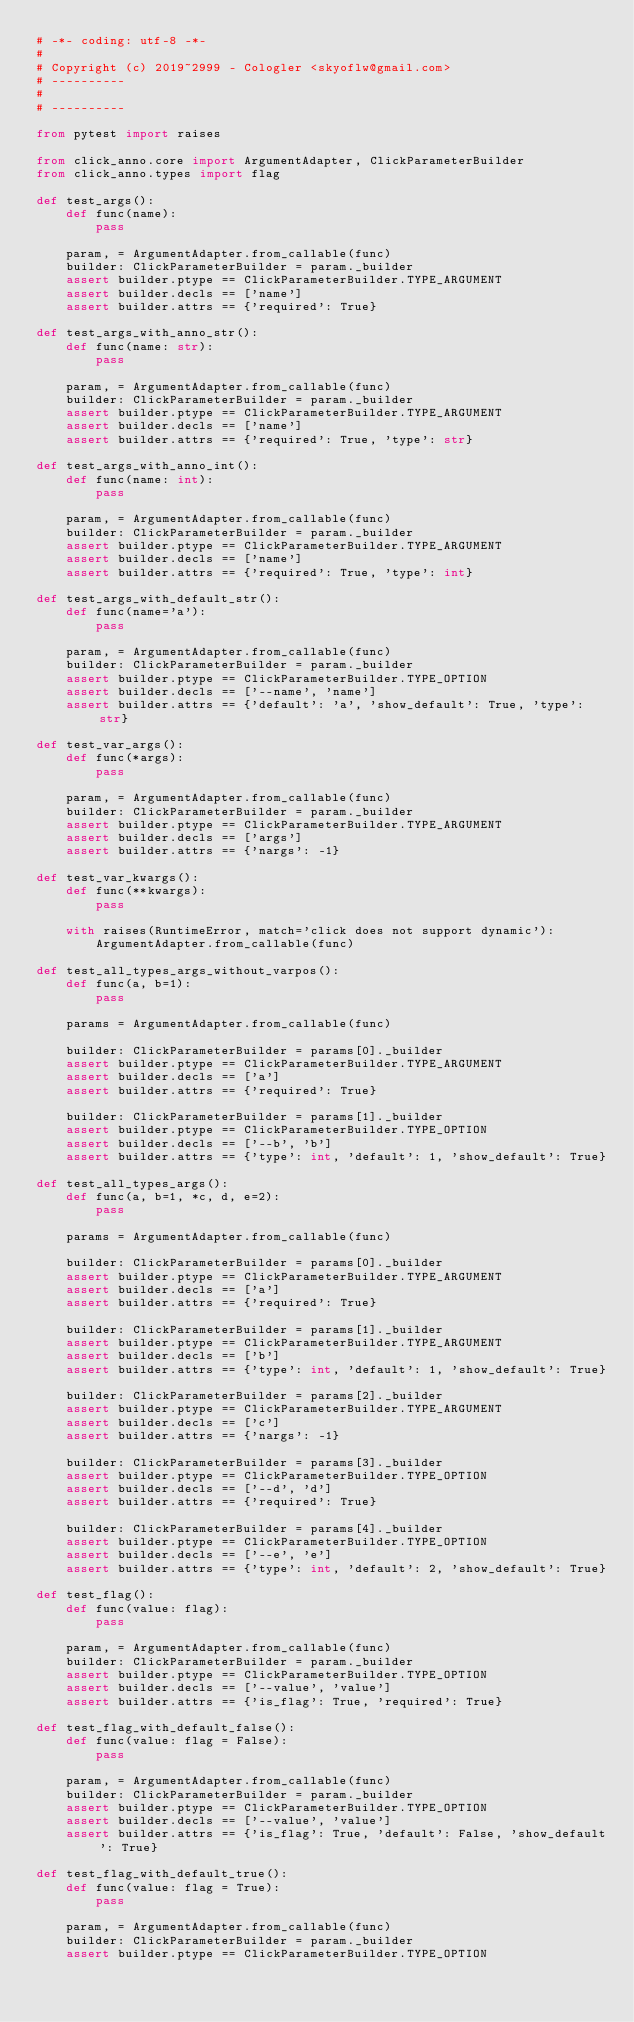<code> <loc_0><loc_0><loc_500><loc_500><_Python_># -*- coding: utf-8 -*-
#
# Copyright (c) 2019~2999 - Cologler <skyoflw@gmail.com>
# ----------
#
# ----------

from pytest import raises

from click_anno.core import ArgumentAdapter, ClickParameterBuilder
from click_anno.types import flag

def test_args():
    def func(name):
        pass

    param, = ArgumentAdapter.from_callable(func)
    builder: ClickParameterBuilder = param._builder
    assert builder.ptype == ClickParameterBuilder.TYPE_ARGUMENT
    assert builder.decls == ['name']
    assert builder.attrs == {'required': True}

def test_args_with_anno_str():
    def func(name: str):
        pass

    param, = ArgumentAdapter.from_callable(func)
    builder: ClickParameterBuilder = param._builder
    assert builder.ptype == ClickParameterBuilder.TYPE_ARGUMENT
    assert builder.decls == ['name']
    assert builder.attrs == {'required': True, 'type': str}

def test_args_with_anno_int():
    def func(name: int):
        pass

    param, = ArgumentAdapter.from_callable(func)
    builder: ClickParameterBuilder = param._builder
    assert builder.ptype == ClickParameterBuilder.TYPE_ARGUMENT
    assert builder.decls == ['name']
    assert builder.attrs == {'required': True, 'type': int}

def test_args_with_default_str():
    def func(name='a'):
        pass

    param, = ArgumentAdapter.from_callable(func)
    builder: ClickParameterBuilder = param._builder
    assert builder.ptype == ClickParameterBuilder.TYPE_OPTION
    assert builder.decls == ['--name', 'name']
    assert builder.attrs == {'default': 'a', 'show_default': True, 'type': str}

def test_var_args():
    def func(*args):
        pass

    param, = ArgumentAdapter.from_callable(func)
    builder: ClickParameterBuilder = param._builder
    assert builder.ptype == ClickParameterBuilder.TYPE_ARGUMENT
    assert builder.decls == ['args']
    assert builder.attrs == {'nargs': -1}

def test_var_kwargs():
    def func(**kwargs):
        pass

    with raises(RuntimeError, match='click does not support dynamic'):
        ArgumentAdapter.from_callable(func)

def test_all_types_args_without_varpos():
    def func(a, b=1):
        pass

    params = ArgumentAdapter.from_callable(func)

    builder: ClickParameterBuilder = params[0]._builder
    assert builder.ptype == ClickParameterBuilder.TYPE_ARGUMENT
    assert builder.decls == ['a']
    assert builder.attrs == {'required': True}

    builder: ClickParameterBuilder = params[1]._builder
    assert builder.ptype == ClickParameterBuilder.TYPE_OPTION
    assert builder.decls == ['--b', 'b']
    assert builder.attrs == {'type': int, 'default': 1, 'show_default': True}

def test_all_types_args():
    def func(a, b=1, *c, d, e=2):
        pass

    params = ArgumentAdapter.from_callable(func)

    builder: ClickParameterBuilder = params[0]._builder
    assert builder.ptype == ClickParameterBuilder.TYPE_ARGUMENT
    assert builder.decls == ['a']
    assert builder.attrs == {'required': True}

    builder: ClickParameterBuilder = params[1]._builder
    assert builder.ptype == ClickParameterBuilder.TYPE_ARGUMENT
    assert builder.decls == ['b']
    assert builder.attrs == {'type': int, 'default': 1, 'show_default': True}

    builder: ClickParameterBuilder = params[2]._builder
    assert builder.ptype == ClickParameterBuilder.TYPE_ARGUMENT
    assert builder.decls == ['c']
    assert builder.attrs == {'nargs': -1}

    builder: ClickParameterBuilder = params[3]._builder
    assert builder.ptype == ClickParameterBuilder.TYPE_OPTION
    assert builder.decls == ['--d', 'd']
    assert builder.attrs == {'required': True}

    builder: ClickParameterBuilder = params[4]._builder
    assert builder.ptype == ClickParameterBuilder.TYPE_OPTION
    assert builder.decls == ['--e', 'e']
    assert builder.attrs == {'type': int, 'default': 2, 'show_default': True}

def test_flag():
    def func(value: flag):
        pass

    param, = ArgumentAdapter.from_callable(func)
    builder: ClickParameterBuilder = param._builder
    assert builder.ptype == ClickParameterBuilder.TYPE_OPTION
    assert builder.decls == ['--value', 'value']
    assert builder.attrs == {'is_flag': True, 'required': True}

def test_flag_with_default_false():
    def func(value: flag = False):
        pass

    param, = ArgumentAdapter.from_callable(func)
    builder: ClickParameterBuilder = param._builder
    assert builder.ptype == ClickParameterBuilder.TYPE_OPTION
    assert builder.decls == ['--value', 'value']
    assert builder.attrs == {'is_flag': True, 'default': False, 'show_default': True}

def test_flag_with_default_true():
    def func(value: flag = True):
        pass

    param, = ArgumentAdapter.from_callable(func)
    builder: ClickParameterBuilder = param._builder
    assert builder.ptype == ClickParameterBuilder.TYPE_OPTION</code> 